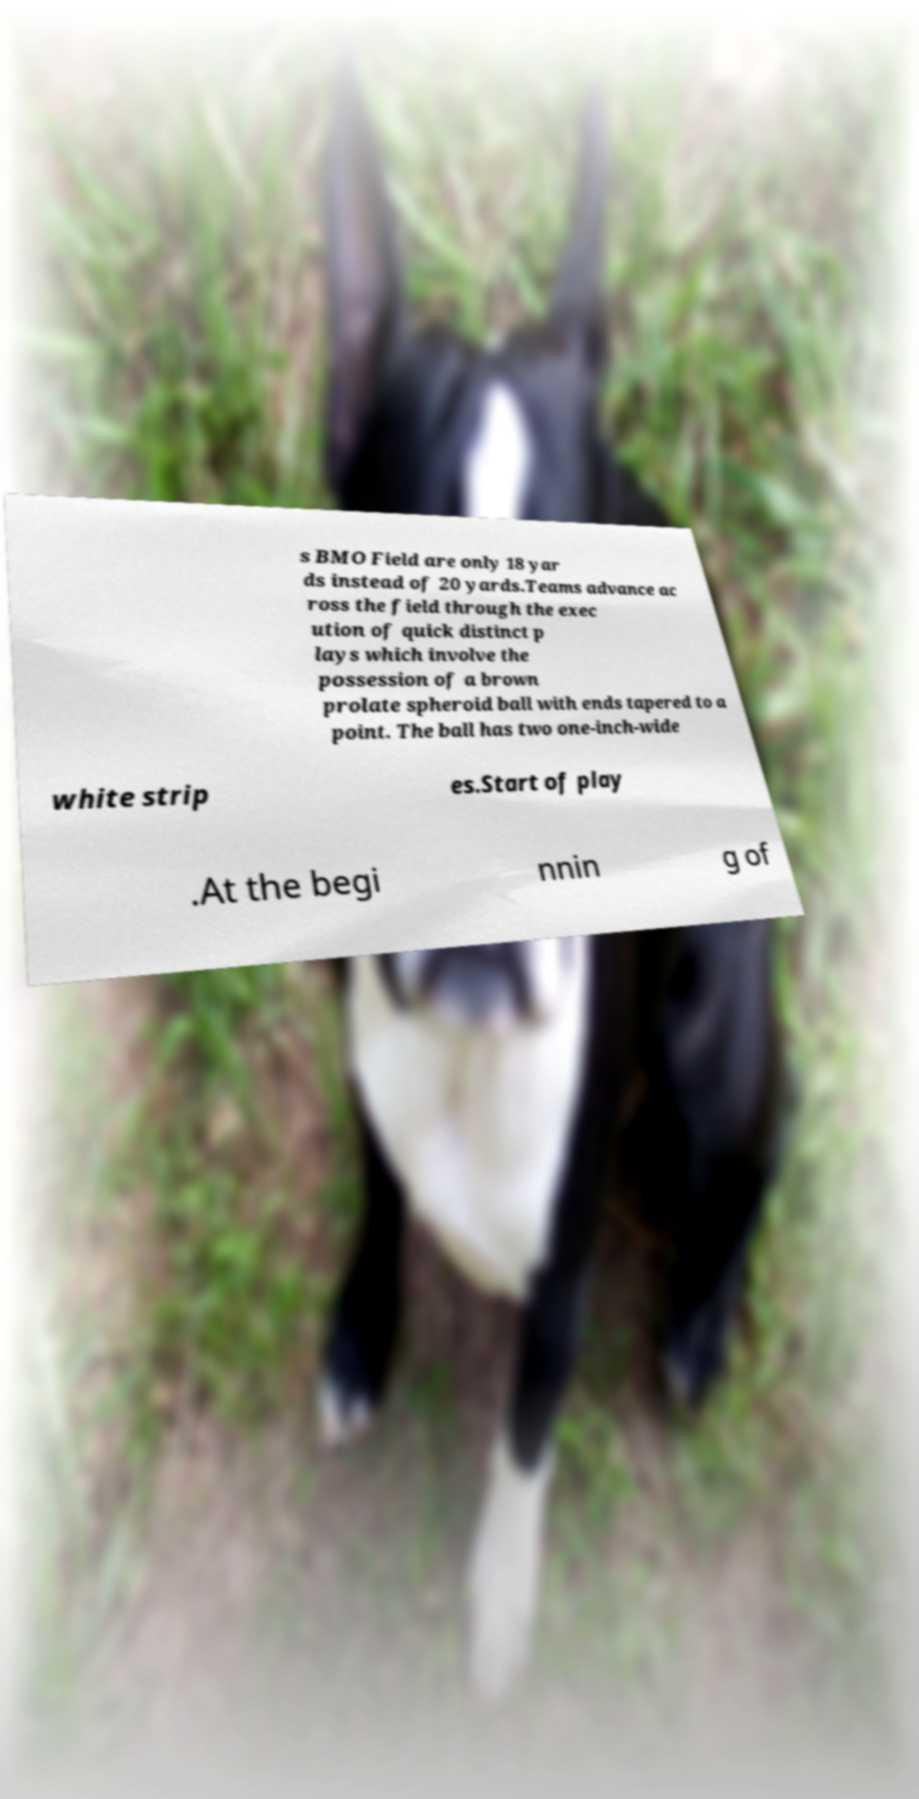Could you assist in decoding the text presented in this image and type it out clearly? s BMO Field are only 18 yar ds instead of 20 yards.Teams advance ac ross the field through the exec ution of quick distinct p lays which involve the possession of a brown prolate spheroid ball with ends tapered to a point. The ball has two one-inch-wide white strip es.Start of play .At the begi nnin g of 